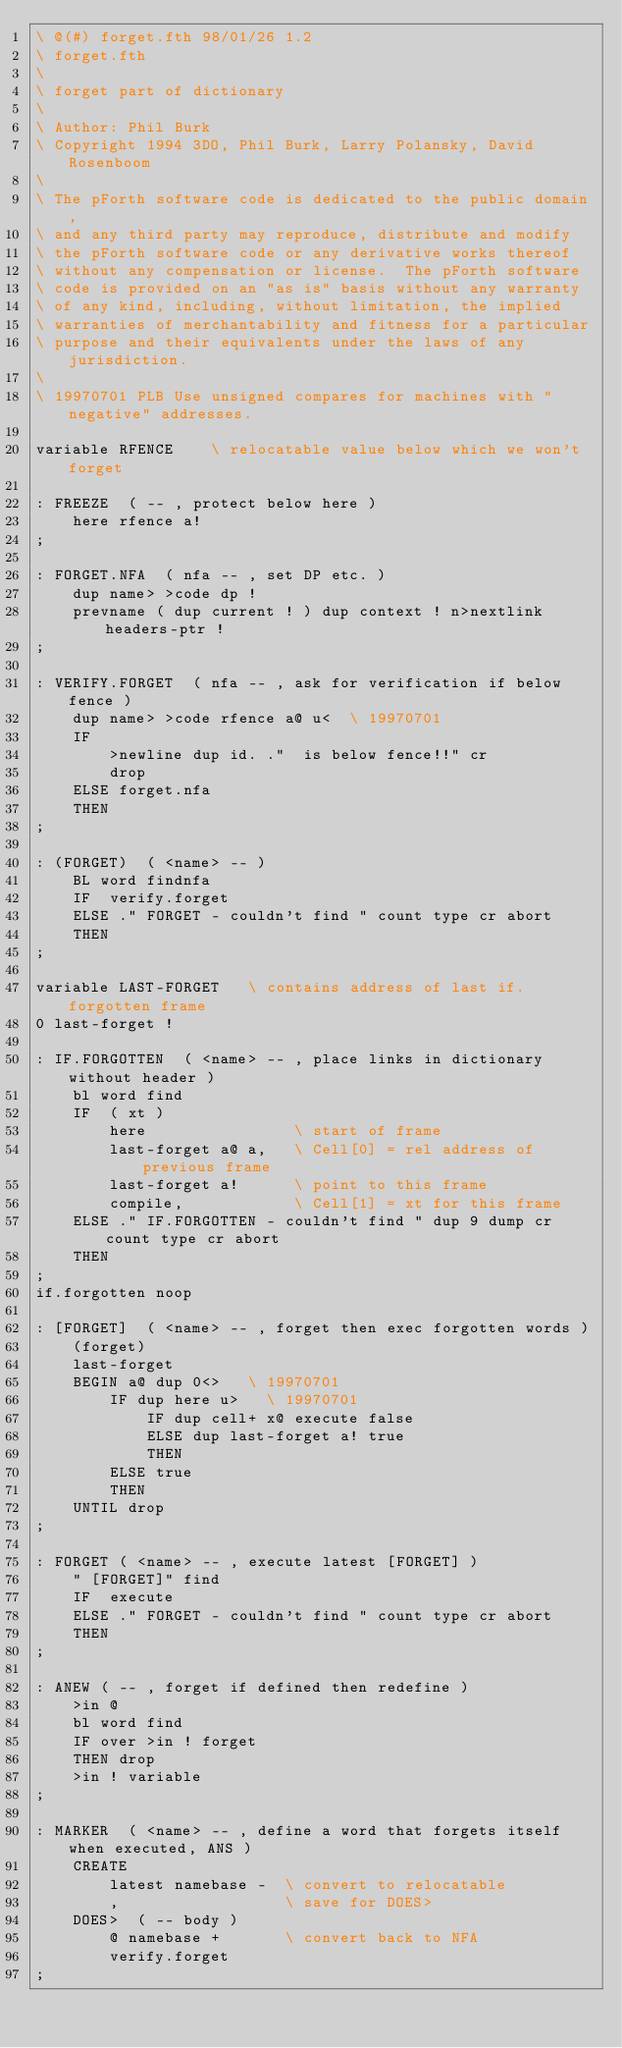<code> <loc_0><loc_0><loc_500><loc_500><_Forth_>\ @(#) forget.fth 98/01/26 1.2
\ forget.fth
\
\ forget part of dictionary
\
\ Author: Phil Burk
\ Copyright 1994 3DO, Phil Burk, Larry Polansky, David Rosenboom
\
\ The pForth software code is dedicated to the public domain,
\ and any third party may reproduce, distribute and modify
\ the pForth software code or any derivative works thereof
\ without any compensation or license.  The pForth software
\ code is provided on an "as is" basis without any warranty
\ of any kind, including, without limitation, the implied
\ warranties of merchantability and fitness for a particular
\ purpose and their equivalents under the laws of any jurisdiction.
\
\ 19970701 PLB Use unsigned compares for machines with "negative" addresses.

variable RFENCE    \ relocatable value below which we won't forget

: FREEZE  ( -- , protect below here )
    here rfence a!
;

: FORGET.NFA  ( nfa -- , set DP etc. )
    dup name> >code dp !
    prevname ( dup current ! ) dup context ! n>nextlink headers-ptr !
;

: VERIFY.FORGET  ( nfa -- , ask for verification if below fence )
    dup name> >code rfence a@ u<  \ 19970701
    IF
        >newline dup id. ."  is below fence!!" cr
        drop
    ELSE forget.nfa
    THEN
;

: (FORGET)  ( <name> -- )
    BL word findnfa
    IF  verify.forget
    ELSE ." FORGET - couldn't find " count type cr abort
    THEN
;

variable LAST-FORGET   \ contains address of last if.forgotten frame
0 last-forget !

: IF.FORGOTTEN  ( <name> -- , place links in dictionary without header )
    bl word find
    IF  ( xt )
        here                \ start of frame
        last-forget a@ a,   \ Cell[0] = rel address of previous frame
        last-forget a!      \ point to this frame
        compile,            \ Cell[1] = xt for this frame
    ELSE ." IF.FORGOTTEN - couldn't find " dup 9 dump cr count type cr abort
    THEN
;
if.forgotten noop

: [FORGET]  ( <name> -- , forget then exec forgotten words )
    (forget)
    last-forget
    BEGIN a@ dup 0<>   \ 19970701
        IF dup here u>   \ 19970701
            IF dup cell+ x@ execute false
            ELSE dup last-forget a! true
            THEN
        ELSE true
        THEN
    UNTIL drop
;

: FORGET ( <name> -- , execute latest [FORGET] )
    " [FORGET]" find
    IF  execute
    ELSE ." FORGET - couldn't find " count type cr abort
    THEN
;

: ANEW ( -- , forget if defined then redefine )
    >in @
    bl word find
    IF over >in ! forget
    THEN drop
    >in ! variable
;

: MARKER  ( <name> -- , define a word that forgets itself when executed, ANS )
    CREATE
        latest namebase -  \ convert to relocatable
        ,                  \ save for DOES>
    DOES>  ( -- body )
        @ namebase +       \ convert back to NFA
        verify.forget
;
</code> 